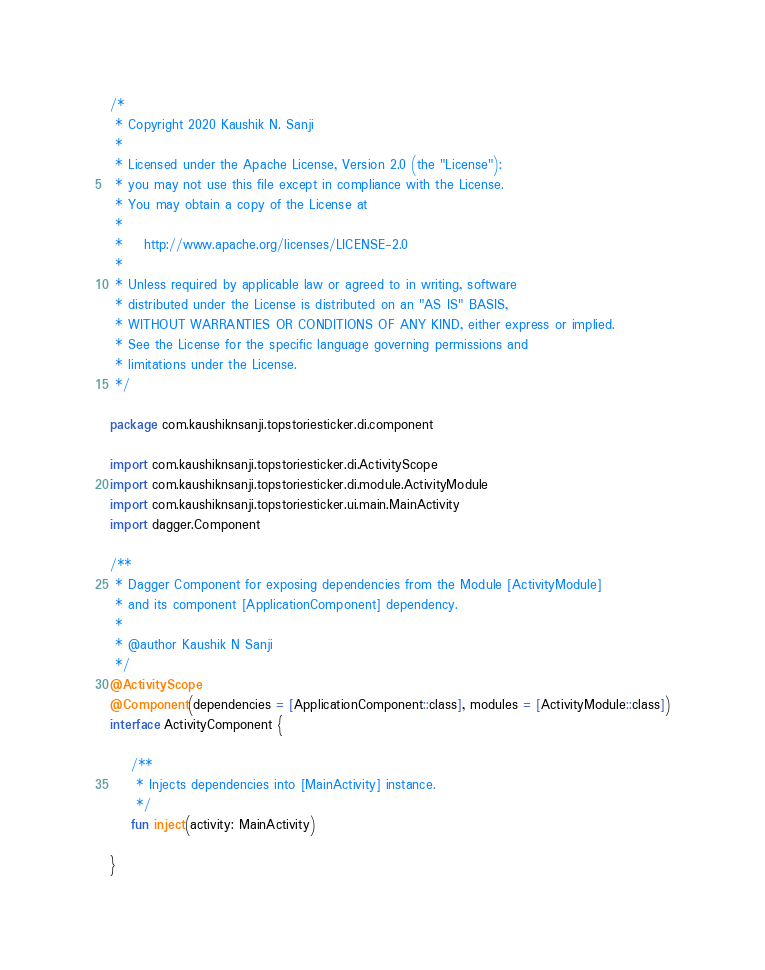Convert code to text. <code><loc_0><loc_0><loc_500><loc_500><_Kotlin_>/*
 * Copyright 2020 Kaushik N. Sanji
 *
 * Licensed under the Apache License, Version 2.0 (the "License");
 * you may not use this file except in compliance with the License.
 * You may obtain a copy of the License at
 *
 *    http://www.apache.org/licenses/LICENSE-2.0
 *
 * Unless required by applicable law or agreed to in writing, software
 * distributed under the License is distributed on an "AS IS" BASIS,
 * WITHOUT WARRANTIES OR CONDITIONS OF ANY KIND, either express or implied.
 * See the License for the specific language governing permissions and
 * limitations under the License.
 */

package com.kaushiknsanji.topstoriesticker.di.component

import com.kaushiknsanji.topstoriesticker.di.ActivityScope
import com.kaushiknsanji.topstoriesticker.di.module.ActivityModule
import com.kaushiknsanji.topstoriesticker.ui.main.MainActivity
import dagger.Component

/**
 * Dagger Component for exposing dependencies from the Module [ActivityModule]
 * and its component [ApplicationComponent] dependency.
 *
 * @author Kaushik N Sanji
 */
@ActivityScope
@Component(dependencies = [ApplicationComponent::class], modules = [ActivityModule::class])
interface ActivityComponent {

    /**
     * Injects dependencies into [MainActivity] instance.
     */
    fun inject(activity: MainActivity)

}</code> 